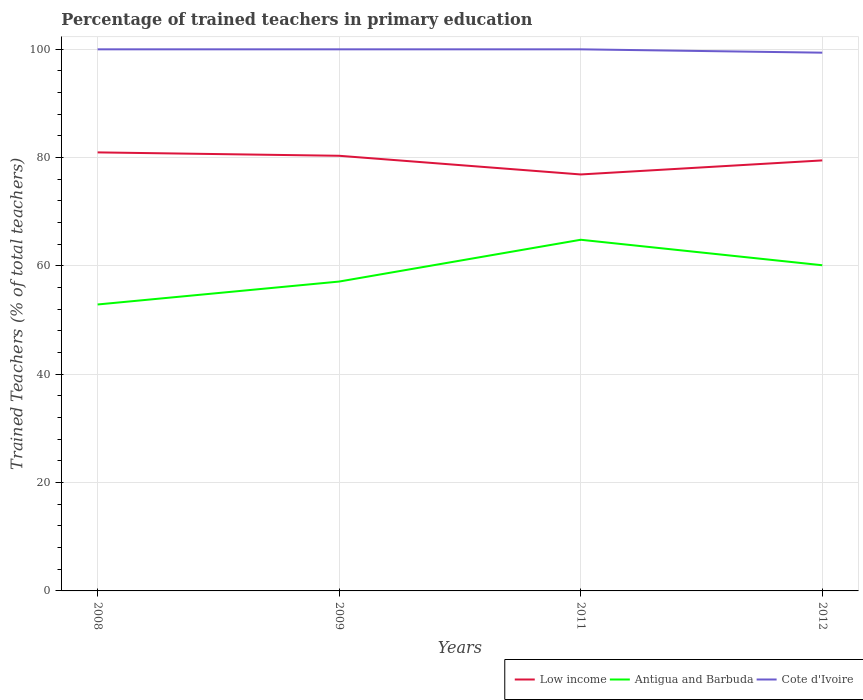How many different coloured lines are there?
Your response must be concise. 3. Does the line corresponding to Antigua and Barbuda intersect with the line corresponding to Low income?
Offer a terse response. No. Across all years, what is the maximum percentage of trained teachers in Cote d'Ivoire?
Offer a terse response. 99.38. What is the total percentage of trained teachers in Antigua and Barbuda in the graph?
Your answer should be compact. -11.95. What is the difference between the highest and the second highest percentage of trained teachers in Antigua and Barbuda?
Give a very brief answer. 11.95. How many years are there in the graph?
Provide a succinct answer. 4. What is the difference between two consecutive major ticks on the Y-axis?
Your response must be concise. 20. Does the graph contain grids?
Your answer should be very brief. Yes. How many legend labels are there?
Provide a short and direct response. 3. What is the title of the graph?
Give a very brief answer. Percentage of trained teachers in primary education. What is the label or title of the Y-axis?
Give a very brief answer. Trained Teachers (% of total teachers). What is the Trained Teachers (% of total teachers) of Low income in 2008?
Provide a succinct answer. 80.97. What is the Trained Teachers (% of total teachers) of Antigua and Barbuda in 2008?
Keep it short and to the point. 52.89. What is the Trained Teachers (% of total teachers) of Cote d'Ivoire in 2008?
Offer a very short reply. 100. What is the Trained Teachers (% of total teachers) in Low income in 2009?
Offer a very short reply. 80.35. What is the Trained Teachers (% of total teachers) in Antigua and Barbuda in 2009?
Your response must be concise. 57.12. What is the Trained Teachers (% of total teachers) of Cote d'Ivoire in 2009?
Give a very brief answer. 100. What is the Trained Teachers (% of total teachers) in Low income in 2011?
Ensure brevity in your answer.  76.9. What is the Trained Teachers (% of total teachers) in Antigua and Barbuda in 2011?
Offer a very short reply. 64.84. What is the Trained Teachers (% of total teachers) of Cote d'Ivoire in 2011?
Give a very brief answer. 100. What is the Trained Teachers (% of total teachers) of Low income in 2012?
Keep it short and to the point. 79.49. What is the Trained Teachers (% of total teachers) of Antigua and Barbuda in 2012?
Your response must be concise. 60.13. What is the Trained Teachers (% of total teachers) of Cote d'Ivoire in 2012?
Give a very brief answer. 99.38. Across all years, what is the maximum Trained Teachers (% of total teachers) of Low income?
Your response must be concise. 80.97. Across all years, what is the maximum Trained Teachers (% of total teachers) of Antigua and Barbuda?
Offer a very short reply. 64.84. Across all years, what is the maximum Trained Teachers (% of total teachers) in Cote d'Ivoire?
Keep it short and to the point. 100. Across all years, what is the minimum Trained Teachers (% of total teachers) of Low income?
Your answer should be compact. 76.9. Across all years, what is the minimum Trained Teachers (% of total teachers) in Antigua and Barbuda?
Give a very brief answer. 52.89. Across all years, what is the minimum Trained Teachers (% of total teachers) of Cote d'Ivoire?
Offer a very short reply. 99.38. What is the total Trained Teachers (% of total teachers) of Low income in the graph?
Provide a succinct answer. 317.7. What is the total Trained Teachers (% of total teachers) in Antigua and Barbuda in the graph?
Your response must be concise. 234.98. What is the total Trained Teachers (% of total teachers) in Cote d'Ivoire in the graph?
Make the answer very short. 399.38. What is the difference between the Trained Teachers (% of total teachers) in Low income in 2008 and that in 2009?
Provide a succinct answer. 0.62. What is the difference between the Trained Teachers (% of total teachers) in Antigua and Barbuda in 2008 and that in 2009?
Your response must be concise. -4.23. What is the difference between the Trained Teachers (% of total teachers) of Low income in 2008 and that in 2011?
Provide a succinct answer. 4.07. What is the difference between the Trained Teachers (% of total teachers) of Antigua and Barbuda in 2008 and that in 2011?
Offer a terse response. -11.95. What is the difference between the Trained Teachers (% of total teachers) in Cote d'Ivoire in 2008 and that in 2011?
Your answer should be compact. 0. What is the difference between the Trained Teachers (% of total teachers) of Low income in 2008 and that in 2012?
Provide a short and direct response. 1.48. What is the difference between the Trained Teachers (% of total teachers) in Antigua and Barbuda in 2008 and that in 2012?
Your answer should be very brief. -7.24. What is the difference between the Trained Teachers (% of total teachers) in Cote d'Ivoire in 2008 and that in 2012?
Your response must be concise. 0.62. What is the difference between the Trained Teachers (% of total teachers) of Low income in 2009 and that in 2011?
Keep it short and to the point. 3.45. What is the difference between the Trained Teachers (% of total teachers) in Antigua and Barbuda in 2009 and that in 2011?
Offer a very short reply. -7.72. What is the difference between the Trained Teachers (% of total teachers) in Low income in 2009 and that in 2012?
Ensure brevity in your answer.  0.85. What is the difference between the Trained Teachers (% of total teachers) in Antigua and Barbuda in 2009 and that in 2012?
Offer a very short reply. -3.01. What is the difference between the Trained Teachers (% of total teachers) in Cote d'Ivoire in 2009 and that in 2012?
Give a very brief answer. 0.62. What is the difference between the Trained Teachers (% of total teachers) of Low income in 2011 and that in 2012?
Keep it short and to the point. -2.59. What is the difference between the Trained Teachers (% of total teachers) of Antigua and Barbuda in 2011 and that in 2012?
Offer a terse response. 4.71. What is the difference between the Trained Teachers (% of total teachers) of Cote d'Ivoire in 2011 and that in 2012?
Offer a terse response. 0.62. What is the difference between the Trained Teachers (% of total teachers) of Low income in 2008 and the Trained Teachers (% of total teachers) of Antigua and Barbuda in 2009?
Ensure brevity in your answer.  23.85. What is the difference between the Trained Teachers (% of total teachers) in Low income in 2008 and the Trained Teachers (% of total teachers) in Cote d'Ivoire in 2009?
Give a very brief answer. -19.03. What is the difference between the Trained Teachers (% of total teachers) in Antigua and Barbuda in 2008 and the Trained Teachers (% of total teachers) in Cote d'Ivoire in 2009?
Provide a succinct answer. -47.11. What is the difference between the Trained Teachers (% of total teachers) in Low income in 2008 and the Trained Teachers (% of total teachers) in Antigua and Barbuda in 2011?
Give a very brief answer. 16.13. What is the difference between the Trained Teachers (% of total teachers) of Low income in 2008 and the Trained Teachers (% of total teachers) of Cote d'Ivoire in 2011?
Make the answer very short. -19.03. What is the difference between the Trained Teachers (% of total teachers) of Antigua and Barbuda in 2008 and the Trained Teachers (% of total teachers) of Cote d'Ivoire in 2011?
Your answer should be very brief. -47.11. What is the difference between the Trained Teachers (% of total teachers) in Low income in 2008 and the Trained Teachers (% of total teachers) in Antigua and Barbuda in 2012?
Offer a terse response. 20.84. What is the difference between the Trained Teachers (% of total teachers) in Low income in 2008 and the Trained Teachers (% of total teachers) in Cote d'Ivoire in 2012?
Provide a short and direct response. -18.41. What is the difference between the Trained Teachers (% of total teachers) of Antigua and Barbuda in 2008 and the Trained Teachers (% of total teachers) of Cote d'Ivoire in 2012?
Provide a succinct answer. -46.5. What is the difference between the Trained Teachers (% of total teachers) in Low income in 2009 and the Trained Teachers (% of total teachers) in Antigua and Barbuda in 2011?
Keep it short and to the point. 15.51. What is the difference between the Trained Teachers (% of total teachers) of Low income in 2009 and the Trained Teachers (% of total teachers) of Cote d'Ivoire in 2011?
Your answer should be very brief. -19.65. What is the difference between the Trained Teachers (% of total teachers) in Antigua and Barbuda in 2009 and the Trained Teachers (% of total teachers) in Cote d'Ivoire in 2011?
Provide a succinct answer. -42.88. What is the difference between the Trained Teachers (% of total teachers) of Low income in 2009 and the Trained Teachers (% of total teachers) of Antigua and Barbuda in 2012?
Your answer should be very brief. 20.21. What is the difference between the Trained Teachers (% of total teachers) in Low income in 2009 and the Trained Teachers (% of total teachers) in Cote d'Ivoire in 2012?
Provide a short and direct response. -19.04. What is the difference between the Trained Teachers (% of total teachers) in Antigua and Barbuda in 2009 and the Trained Teachers (% of total teachers) in Cote d'Ivoire in 2012?
Ensure brevity in your answer.  -42.26. What is the difference between the Trained Teachers (% of total teachers) in Low income in 2011 and the Trained Teachers (% of total teachers) in Antigua and Barbuda in 2012?
Offer a terse response. 16.76. What is the difference between the Trained Teachers (% of total teachers) of Low income in 2011 and the Trained Teachers (% of total teachers) of Cote d'Ivoire in 2012?
Keep it short and to the point. -22.49. What is the difference between the Trained Teachers (% of total teachers) in Antigua and Barbuda in 2011 and the Trained Teachers (% of total teachers) in Cote d'Ivoire in 2012?
Your answer should be compact. -34.54. What is the average Trained Teachers (% of total teachers) of Low income per year?
Give a very brief answer. 79.43. What is the average Trained Teachers (% of total teachers) of Antigua and Barbuda per year?
Make the answer very short. 58.75. What is the average Trained Teachers (% of total teachers) in Cote d'Ivoire per year?
Offer a terse response. 99.85. In the year 2008, what is the difference between the Trained Teachers (% of total teachers) of Low income and Trained Teachers (% of total teachers) of Antigua and Barbuda?
Make the answer very short. 28.08. In the year 2008, what is the difference between the Trained Teachers (% of total teachers) of Low income and Trained Teachers (% of total teachers) of Cote d'Ivoire?
Ensure brevity in your answer.  -19.03. In the year 2008, what is the difference between the Trained Teachers (% of total teachers) in Antigua and Barbuda and Trained Teachers (% of total teachers) in Cote d'Ivoire?
Make the answer very short. -47.11. In the year 2009, what is the difference between the Trained Teachers (% of total teachers) in Low income and Trained Teachers (% of total teachers) in Antigua and Barbuda?
Your response must be concise. 23.22. In the year 2009, what is the difference between the Trained Teachers (% of total teachers) in Low income and Trained Teachers (% of total teachers) in Cote d'Ivoire?
Give a very brief answer. -19.65. In the year 2009, what is the difference between the Trained Teachers (% of total teachers) of Antigua and Barbuda and Trained Teachers (% of total teachers) of Cote d'Ivoire?
Your answer should be compact. -42.88. In the year 2011, what is the difference between the Trained Teachers (% of total teachers) of Low income and Trained Teachers (% of total teachers) of Antigua and Barbuda?
Provide a short and direct response. 12.06. In the year 2011, what is the difference between the Trained Teachers (% of total teachers) of Low income and Trained Teachers (% of total teachers) of Cote d'Ivoire?
Provide a short and direct response. -23.1. In the year 2011, what is the difference between the Trained Teachers (% of total teachers) of Antigua and Barbuda and Trained Teachers (% of total teachers) of Cote d'Ivoire?
Give a very brief answer. -35.16. In the year 2012, what is the difference between the Trained Teachers (% of total teachers) of Low income and Trained Teachers (% of total teachers) of Antigua and Barbuda?
Give a very brief answer. 19.36. In the year 2012, what is the difference between the Trained Teachers (% of total teachers) in Low income and Trained Teachers (% of total teachers) in Cote d'Ivoire?
Your answer should be very brief. -19.89. In the year 2012, what is the difference between the Trained Teachers (% of total teachers) in Antigua and Barbuda and Trained Teachers (% of total teachers) in Cote d'Ivoire?
Provide a succinct answer. -39.25. What is the ratio of the Trained Teachers (% of total teachers) in Low income in 2008 to that in 2009?
Your answer should be compact. 1.01. What is the ratio of the Trained Teachers (% of total teachers) in Antigua and Barbuda in 2008 to that in 2009?
Your response must be concise. 0.93. What is the ratio of the Trained Teachers (% of total teachers) of Low income in 2008 to that in 2011?
Keep it short and to the point. 1.05. What is the ratio of the Trained Teachers (% of total teachers) in Antigua and Barbuda in 2008 to that in 2011?
Make the answer very short. 0.82. What is the ratio of the Trained Teachers (% of total teachers) in Cote d'Ivoire in 2008 to that in 2011?
Provide a succinct answer. 1. What is the ratio of the Trained Teachers (% of total teachers) in Low income in 2008 to that in 2012?
Provide a short and direct response. 1.02. What is the ratio of the Trained Teachers (% of total teachers) in Antigua and Barbuda in 2008 to that in 2012?
Offer a very short reply. 0.88. What is the ratio of the Trained Teachers (% of total teachers) of Low income in 2009 to that in 2011?
Offer a very short reply. 1.04. What is the ratio of the Trained Teachers (% of total teachers) in Antigua and Barbuda in 2009 to that in 2011?
Give a very brief answer. 0.88. What is the ratio of the Trained Teachers (% of total teachers) in Low income in 2009 to that in 2012?
Provide a short and direct response. 1.01. What is the ratio of the Trained Teachers (% of total teachers) in Antigua and Barbuda in 2009 to that in 2012?
Your response must be concise. 0.95. What is the ratio of the Trained Teachers (% of total teachers) of Low income in 2011 to that in 2012?
Make the answer very short. 0.97. What is the ratio of the Trained Teachers (% of total teachers) in Antigua and Barbuda in 2011 to that in 2012?
Your response must be concise. 1.08. What is the ratio of the Trained Teachers (% of total teachers) of Cote d'Ivoire in 2011 to that in 2012?
Your response must be concise. 1.01. What is the difference between the highest and the second highest Trained Teachers (% of total teachers) in Low income?
Offer a terse response. 0.62. What is the difference between the highest and the second highest Trained Teachers (% of total teachers) in Antigua and Barbuda?
Your response must be concise. 4.71. What is the difference between the highest and the second highest Trained Teachers (% of total teachers) in Cote d'Ivoire?
Offer a very short reply. 0. What is the difference between the highest and the lowest Trained Teachers (% of total teachers) in Low income?
Your answer should be compact. 4.07. What is the difference between the highest and the lowest Trained Teachers (% of total teachers) in Antigua and Barbuda?
Your response must be concise. 11.95. What is the difference between the highest and the lowest Trained Teachers (% of total teachers) in Cote d'Ivoire?
Make the answer very short. 0.62. 